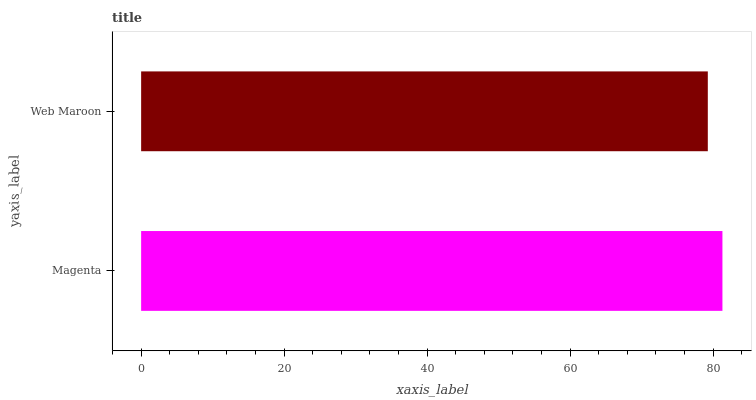Is Web Maroon the minimum?
Answer yes or no. Yes. Is Magenta the maximum?
Answer yes or no. Yes. Is Web Maroon the maximum?
Answer yes or no. No. Is Magenta greater than Web Maroon?
Answer yes or no. Yes. Is Web Maroon less than Magenta?
Answer yes or no. Yes. Is Web Maroon greater than Magenta?
Answer yes or no. No. Is Magenta less than Web Maroon?
Answer yes or no. No. Is Magenta the high median?
Answer yes or no. Yes. Is Web Maroon the low median?
Answer yes or no. Yes. Is Web Maroon the high median?
Answer yes or no. No. Is Magenta the low median?
Answer yes or no. No. 